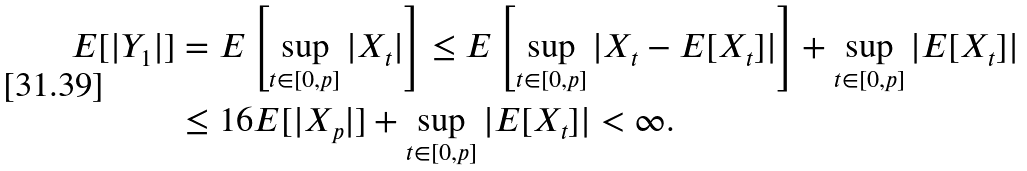<formula> <loc_0><loc_0><loc_500><loc_500>E [ | Y _ { 1 } | ] & = E \left [ \sup _ { t \in [ 0 , p ] } | X _ { t } | \right ] \leq E \left [ \sup _ { t \in [ 0 , p ] } | X _ { t } - E [ X _ { t } ] | \right ] + \sup _ { t \in [ 0 , p ] } | E [ X _ { t } ] | \\ & \leq 1 6 E [ | X _ { p } | ] + \sup _ { t \in [ 0 , p ] } | E [ X _ { t } ] | < \infty .</formula> 